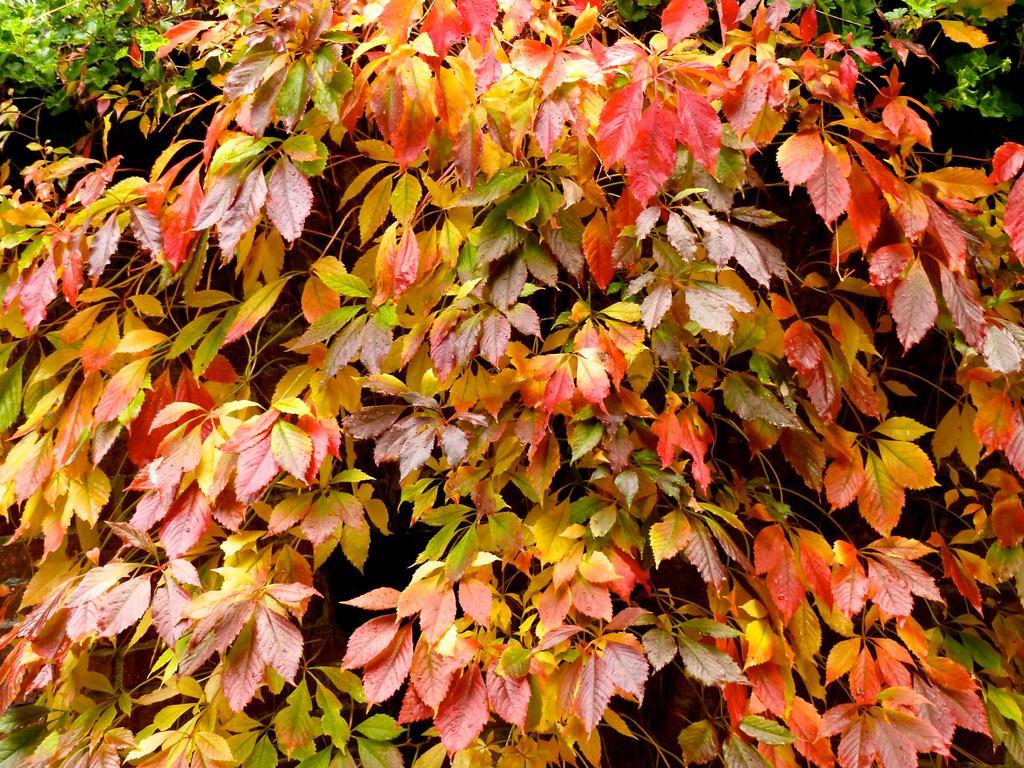Could you give a brief overview of what you see in this image? In the picture we can see many groups of plants with leaves some are red in color, some are yellow in color and some are green in color. 